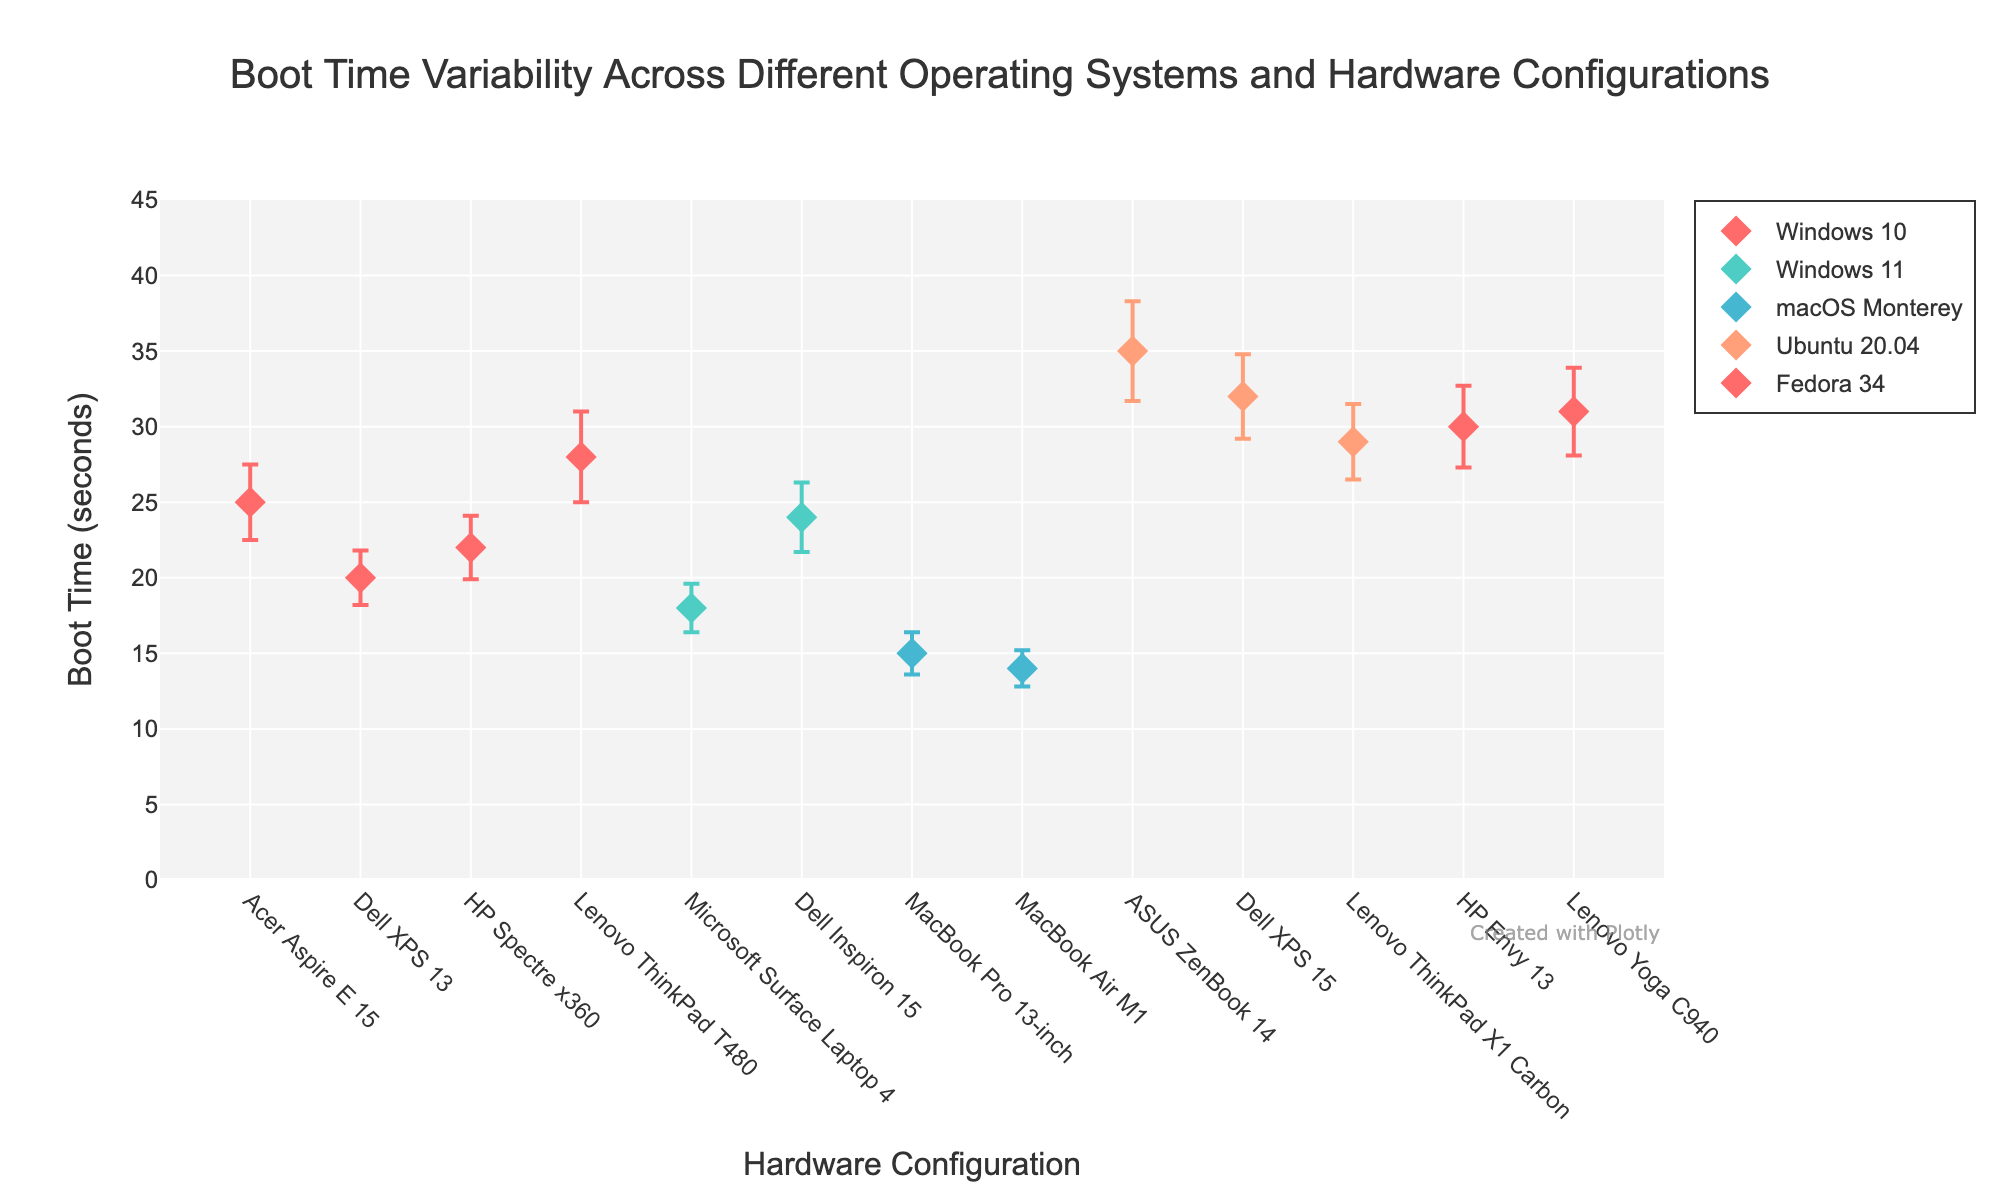Which hardware configuration has the fastest boot time under macOS Monterey? Look for the hardware configuration with the lowest boot time mean under macOS Monterey. The MacBook Air M1 has a boot time mean of 14 seconds, which is the lowest.
Answer: MacBook Air M1 What is the range of boot times for Windows 10 on the Acer Aspire E15? The boot time mean for Windows 10 on the Acer Aspire E15 is 25 seconds with a standard deviation of 2.5 seconds. The boot time range is [25 - 2.5, 25 + 2.5], which is [22.5, 27.5] seconds.
Answer: 22.5 to 27.5 seconds Which operating system and hardware combination has the highest standard deviation in boot time? By comparing the standard deviations, Ubuntu 20.04 on the ASUS ZenBook 14 has the highest standard deviation of 3.3 seconds.
Answer: Ubuntu 20.04 on ASUS ZenBook 14 What is the average boot time for all devices running Windows 11? Calculate the mean boot times for Windows 11 devices: (18 + 24) / 2 = 21 seconds.
Answer: 21 seconds Among Dell XPS models, which one has the lower boot time and under which operating system? Compare the boot times of Dell XPS models: Dell XPS 13 with Windows 10 has a mean boot time of 20 seconds, and Dell XPS 15 with Ubuntu 20.04 has a mean boot time of 32 seconds. The Dell XPS 13 with Windows 10 has the lower boot time.
Answer: Windows 10 on Dell XPS 13 What is the difference in boot time between the MacBook Pro 13-inch and MacBook Air M1? Subtract the boot time mean of the MacBook Air M1 (14 seconds) from the boot time mean of the MacBook Pro 13-inch (15 seconds): 15 - 14 = 1 second.
Answer: 1 second Does any hardware configuration have a boot time standard deviation greater than 3 seconds? Look for any configuration with a standard deviation greater than 3 seconds. The ASUS ZenBook 14 under Ubuntu 20.04 has a standard deviation of 3.3 seconds.
Answer: Yes, ASUS ZenBook 14 under Ubuntu 20.04 Which hardware configuration under Fedora 34 has a higher boot time mean? Compare the boot time means under Fedora 34: HP Envy 13 has 30 seconds, and Lenovo Yoga C940 has 31 seconds. The Lenovo Yoga C940 has a higher boot time mean.
Answer: Lenovo Yoga C940 What is the average and standard deviation of boot times for all Lenovo ThinkPad models across different OSs? Lenovo ThinkPad T480 with Windows 10 (28s, 3.0s), Lenovo ThinkPad X1 Carbon with Ubuntu 20.04 (29s, 2.5s). Mean: (28 + 29) / 2 = 28.5 seconds. Std Dev: sqrt((3^2 + 2.5^2) / 2) ≈ 2.77 seconds.
Answer: 28.5 seconds, 2.77 seconds 